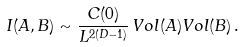<formula> <loc_0><loc_0><loc_500><loc_500>I ( A , B ) \sim \frac { C ( 0 ) } { L ^ { 2 ( D - 1 ) } } \, V o l ( A ) V o l ( B ) \, .</formula> 